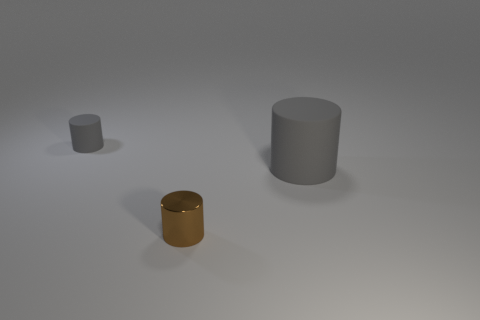Add 1 small yellow rubber things. How many objects exist? 4 Subtract all big cyan rubber balls. Subtract all small shiny things. How many objects are left? 2 Add 3 shiny things. How many shiny things are left? 4 Add 1 small green shiny balls. How many small green shiny balls exist? 1 Subtract 0 yellow cubes. How many objects are left? 3 